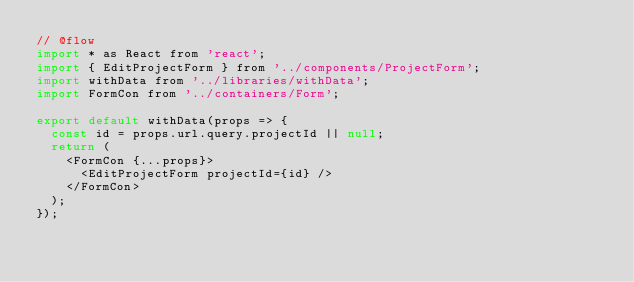Convert code to text. <code><loc_0><loc_0><loc_500><loc_500><_JavaScript_>// @flow
import * as React from 'react';
import { EditProjectForm } from '../components/ProjectForm';
import withData from '../libraries/withData';
import FormCon from '../containers/Form';

export default withData(props => {
  const id = props.url.query.projectId || null;
  return (
    <FormCon {...props}>
      <EditProjectForm projectId={id} />
    </FormCon>
  );
});
</code> 